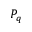<formula> <loc_0><loc_0><loc_500><loc_500>P _ { q }</formula> 